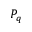<formula> <loc_0><loc_0><loc_500><loc_500>P _ { q }</formula> 